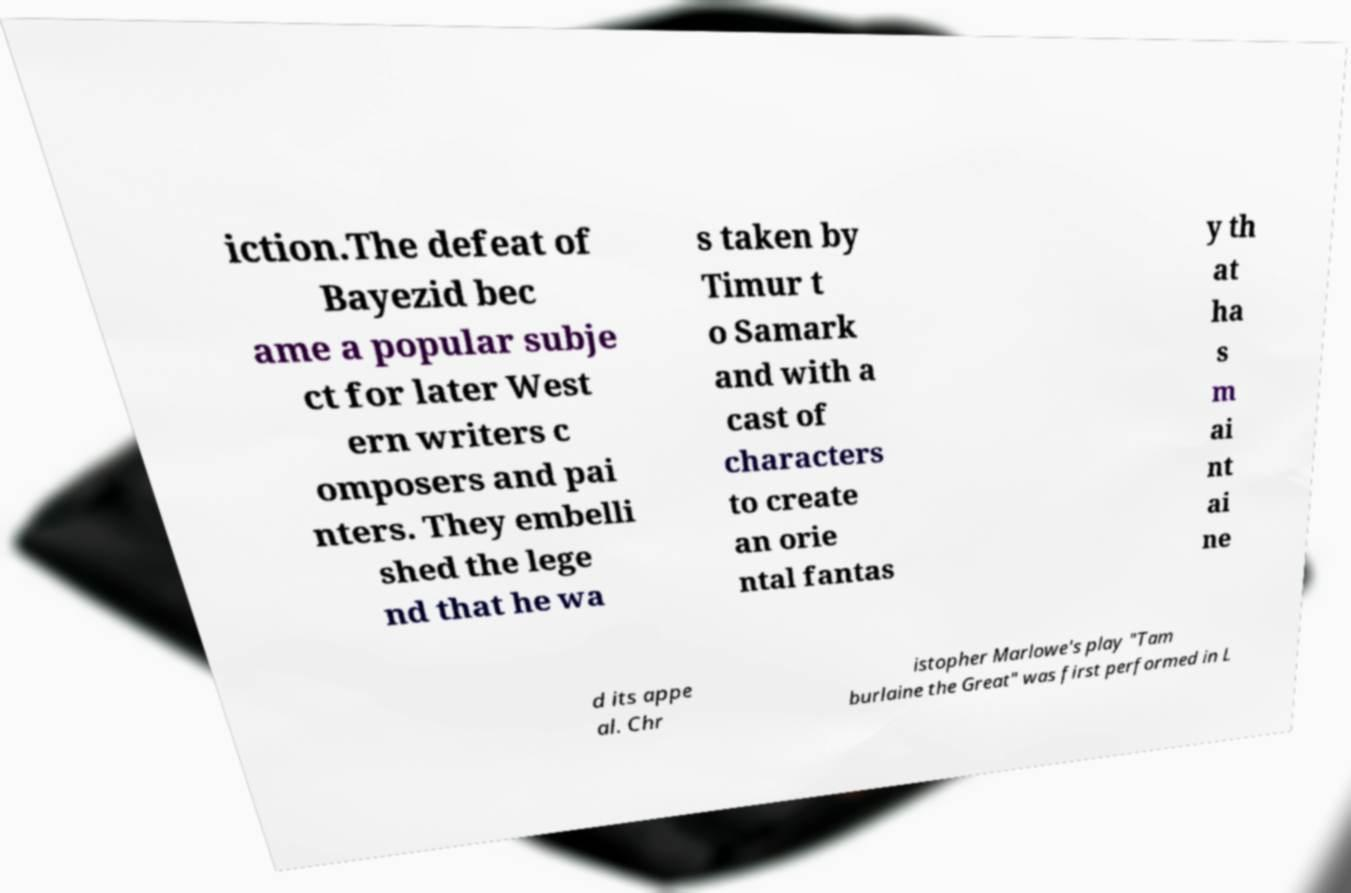There's text embedded in this image that I need extracted. Can you transcribe it verbatim? iction.The defeat of Bayezid bec ame a popular subje ct for later West ern writers c omposers and pai nters. They embelli shed the lege nd that he wa s taken by Timur t o Samark and with a cast of characters to create an orie ntal fantas y th at ha s m ai nt ai ne d its appe al. Chr istopher Marlowe's play "Tam burlaine the Great" was first performed in L 